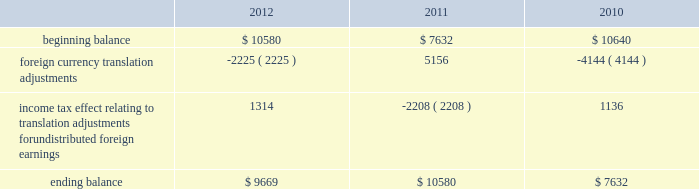The table sets forth the components of foreign currency translation adjustments for fiscal 2012 , 2011 and 2010 ( in thousands ) : .
Stock repurchase program to facilitate our stock repurchase program , designed to return value to our stockholders and minimize dilution from stock issuances , we repurchase shares in the open market and also enter into structured repurchase agreements with third-parties .
Authorization to repurchase shares to cover on-going dilution was not subject to expiration .
However , this repurchase program was limited to covering net dilution from stock issuances and was subject to business conditions and cash flow requirements as determined by our board of directors from time to time .
During the third quarter of fiscal 2010 , our board of directors approved an amendment to our stock repurchase program authorized in april 2007 from a non-expiring share-based authority to a time-constrained dollar-based authority .
As part of this amendment , the board of directors granted authority to repurchase up to $ 1.6 billion in common stock through the end of fiscal 2012 .
During the second quarter of fiscal 2012 , we exhausted our $ 1.6 billion authority granted by our board of directors in fiscal in april 2012 , the board of directors approved a new stock repurchase program granting authority to repurchase up to $ 2.0 billion in common stock through the end of fiscal 2015 .
The new stock repurchase program approved by our board of directors is similar to our previous $ 1.6 billion stock repurchase program .
During fiscal 2012 , 2011 and 2010 , we entered into several structured repurchase agreements with large financial institutions , whereupon we provided the financial institutions with prepayments totaling $ 405.0 million , $ 695.0 million and $ 850 million , respectively .
Of the $ 405.0 million of prepayments during fiscal 2012 , $ 100.0 million was under the new $ 2.0 billion stock repurchase program and the remaining $ 305.0 million was under our previous $ 1.6 billion authority .
Of the $ 850.0 million of prepayments during fiscal 2010 , $ 250.0 million was under the stock repurchase program prior to the program amendment in the third quarter of fiscal 2010 and the remaining $ 600.0 million was under the amended $ 1.6 billion time-constrained dollar-based authority .
We enter into these agreements in order to take advantage of repurchasing shares at a guaranteed discount to the volume weighted average price ( 201cvwap 201d ) of our common stock over a specified period of time .
We only enter into such transactions when the discount that we receive is higher than the foregone return on our cash prepayments to the financial institutions .
There were no explicit commissions or fees on these structured repurchases .
Under the terms of the agreements , there is no requirement for the financial institutions to return any portion of the prepayment to us .
The financial institutions agree to deliver shares to us at monthly intervals during the contract term .
The parameters used to calculate the number of shares deliverable are : the total notional amount of the contract , the number of trading days in the contract , the number of trading days in the interval and the average vwap of our stock during the interval less the agreed upon discount .
During fiscal 2012 , we repurchased approximately 11.5 million shares at an average price of $ 32.29 through structured repurchase agreements entered into during fiscal 2012 .
During fiscal 2011 , we repurchased approximately 21.8 million shares at an average price of $ 31.81 through structured repurchase agreements entered into during fiscal 2011 .
During fiscal 2010 , we repurchased approximately 31.2 million shares at an average price per share of $ 29.19 through structured repurchase agreements entered into during fiscal 2009 and fiscal 2010 .
For fiscal 2012 , 2011 and 2010 , the prepayments were classified as treasury stock on our consolidated balance sheets at the payment date , though only shares physically delivered to us by november 30 , 2012 , december 2 , 2011 and december 3 , 2010 were excluded from the computation of earnings per share .
As of november 30 , 2012 , $ 33.0 million of prepayments remained under these agreements .
As of december 2 , 2011 and december 3 , 2010 , no prepayments remained under these agreements .
Table of contents adobe systems incorporated notes to consolidated financial statements ( continued ) .
What was the change in balance of foreign currency translation adjustments for fiscal 2012 , in thousands? 
Computations: (9669 - 10580)
Answer: -911.0. 